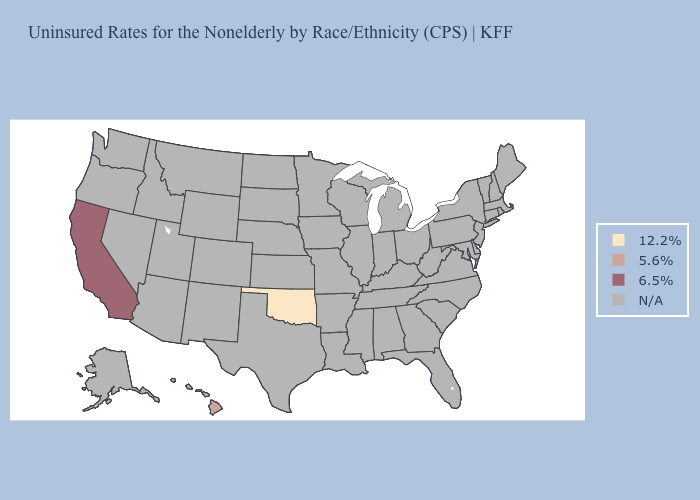Does the first symbol in the legend represent the smallest category?
Keep it brief. Yes. Name the states that have a value in the range 6.5%?
Concise answer only. California. Name the states that have a value in the range 12.2%?
Keep it brief. Oklahoma. What is the value of Virginia?
Be succinct. N/A. Which states have the lowest value in the USA?
Answer briefly. Oklahoma. Is the legend a continuous bar?
Give a very brief answer. No. Name the states that have a value in the range N/A?
Answer briefly. Alabama, Alaska, Arizona, Arkansas, Colorado, Connecticut, Delaware, Florida, Georgia, Idaho, Illinois, Indiana, Iowa, Kansas, Kentucky, Louisiana, Maine, Maryland, Massachusetts, Michigan, Minnesota, Mississippi, Missouri, Montana, Nebraska, Nevada, New Hampshire, New Jersey, New Mexico, New York, North Carolina, North Dakota, Ohio, Oregon, Pennsylvania, Rhode Island, South Carolina, South Dakota, Tennessee, Texas, Utah, Vermont, Virginia, Washington, West Virginia, Wisconsin, Wyoming. Name the states that have a value in the range 5.6%?
Concise answer only. Hawaii. 